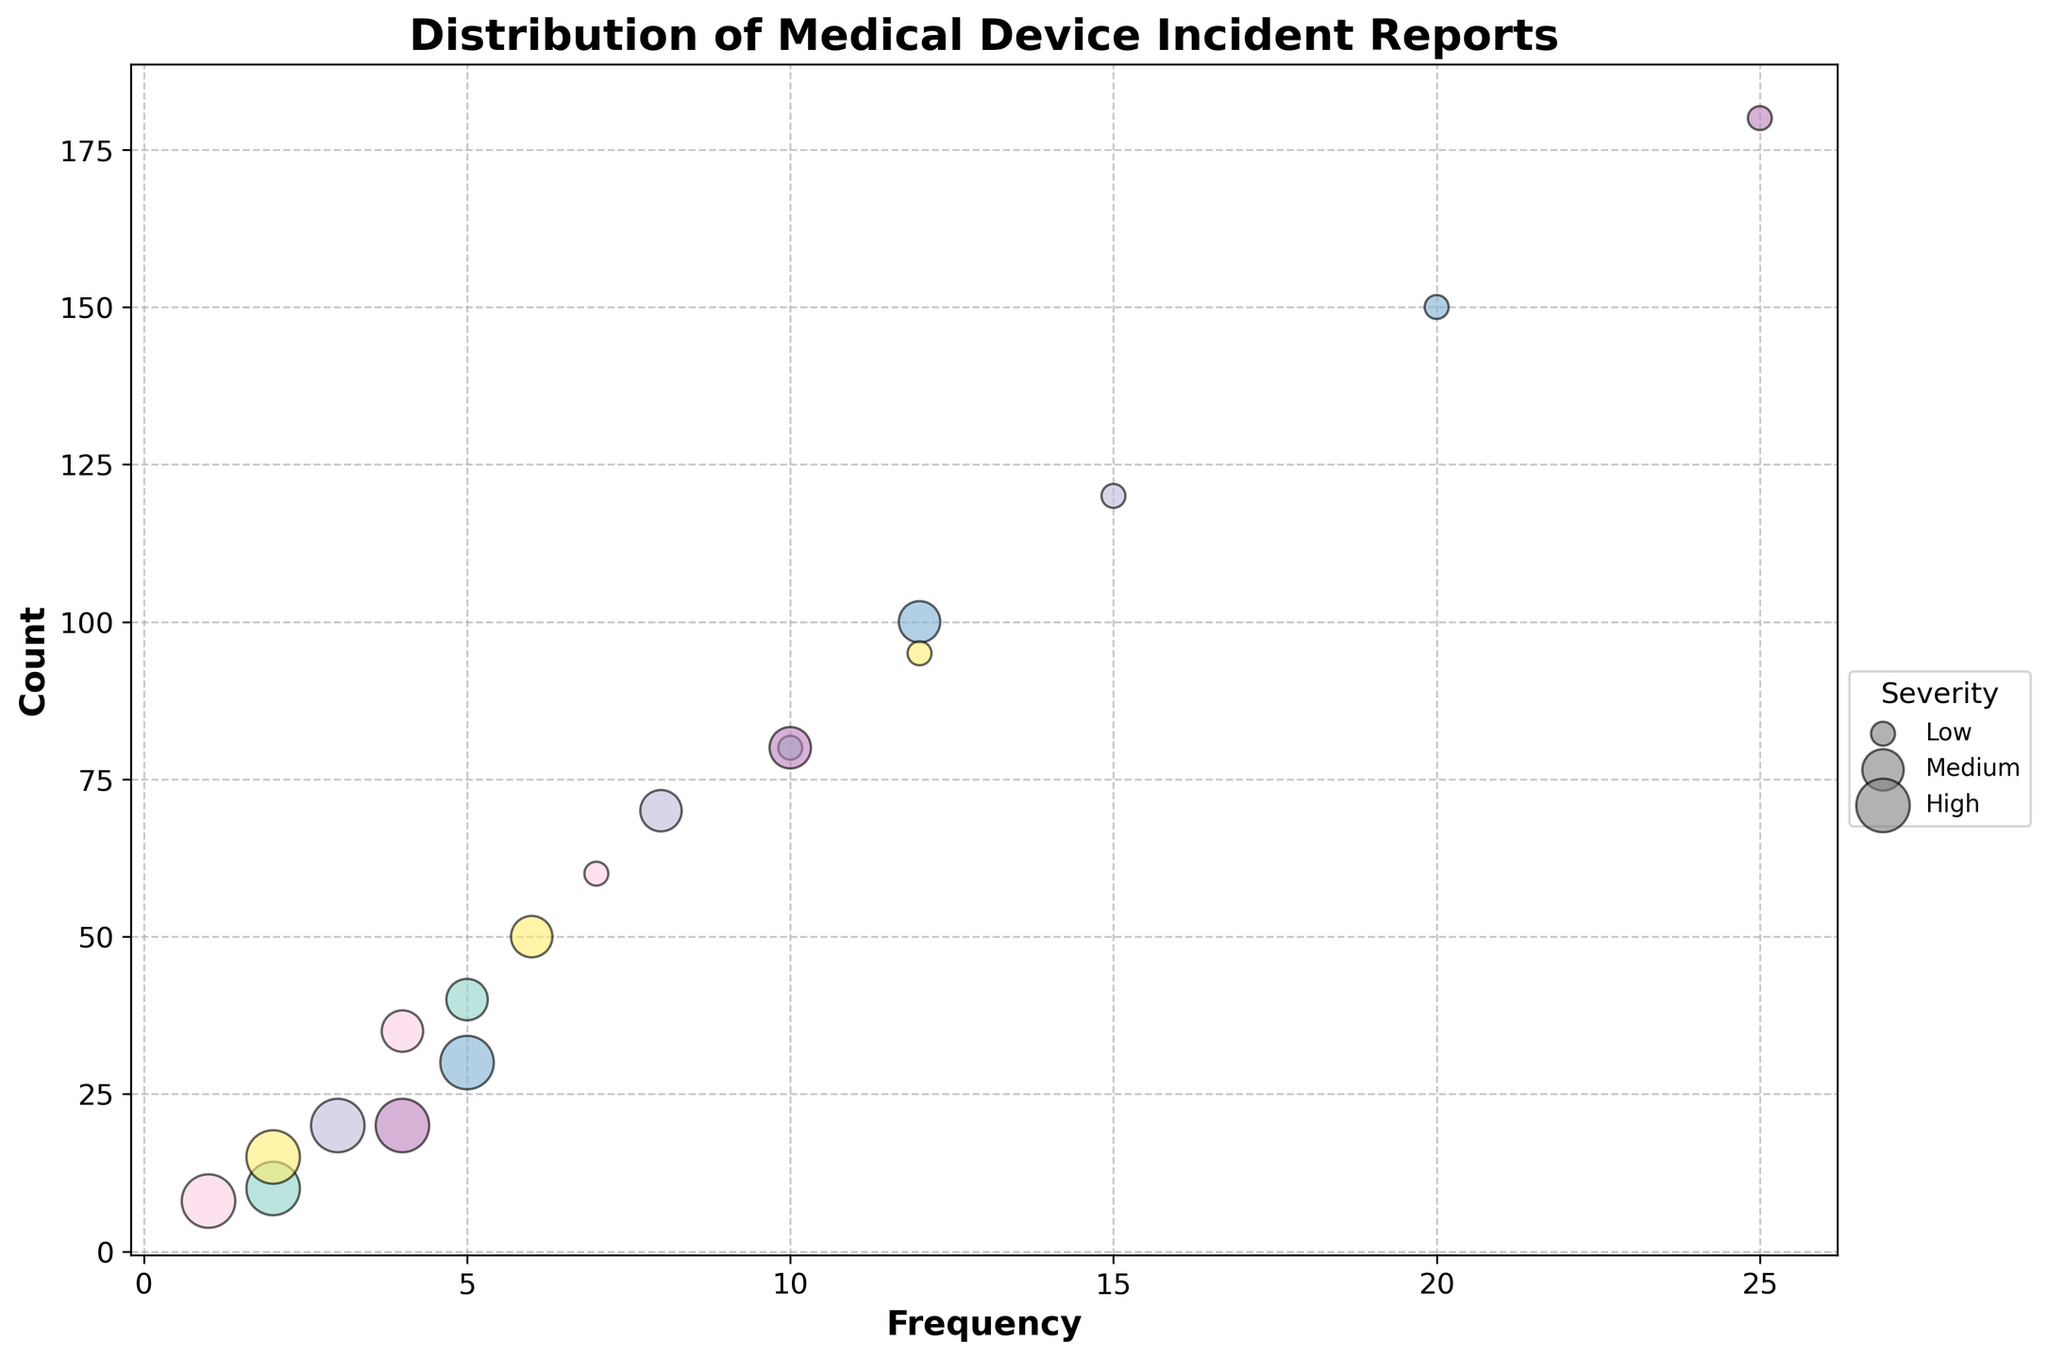what is the title of the figure? The title of the figure is located at the top and provides a summary of what the plot is about. It helps users quickly understand the context. For this chart, the title indicates that it shows the distribution of incident reports for different types of medical devices.
Answer: Distribution of Medical Device Incident Reports how many device types are analyzed in the figure? By observing the unique color-coded legends on the chart, we can count the different device types represented. Each device type is indicated by a different color.
Answer: 6 which device type has the highest count for low severity incidents? To identify this, look for the largest bubble in the "Low" legend category. The bubble with the highest count value will be the largest on the y-axis. This device is the Diagnostic Imaging Device.
Answer: Diagnostic Imaging Device compare the frequency of medium severity incidents between surgical stapler and cardiac pacemaker First, locate the medium severity bubbles for both the Surgical Stapler and the Cardiac Pacemaker on the chart. Compare their position on the x-axis to determine which has a higher frequency.
Answer: Surgical Stapler has a higher frequency than Cardiac Pacemaker which device type appears to have the smallest bubble for high severity incidents? To determine this, locate the smallest bubble under the high severity category in the chart. Compare the bubbles corresponding to each device type with high severity incidents. The Orthopedic Implant has the smallest bubble.
Answer: Orthopedic Implant what is the relationship between frequency and count for the insulin pump in medium severity incidents? Look for the bubble representing medium severity incidents for the Insulin Pump. Identify its position on both the x-axis (frequency) and the y-axis (count). The position indicates that with an increase in frequency (8), the count is 70. This suggests that medium frequency incidents have a higher count for this device.
Answer: Frequency: 8, Count: 70 if you add the counts of high severity incidents for all device types, what is the total? Sum the counts of high severity incidents for each device type: Cardiac Pacemaker (10) + Insulin Pump (20) + Surgical Stapler (30) + Orthopedic Implant (8) + Diagnostic Imaging Device (20) + Dialysis Machine (15).
Answer: 103 which device has the largest bubble overall, and what does it represent? The largest bubble will be the one with the highest count and largest size. Look for the bubble size in all severity categories and determine which device it corresponds to. The Diagnostic Imaging Device with 180 counts and low severity represents the largest bubble.
Answer: Diagnostic Imaging Device (Low severity, 180 counts) for diagnosing frequency of incidents over count, which device shows a positive linear trend in low severity? Observing the positions of the bubbles for low severity, identify a device whose bubbles form a roughly straight line, indicating a positive relationship between frequency and count. For Low severity incidents, Surgical Stapler demonstrates this trend.
Answer: Surgical Stapler what kind of legend elements are used to indicate severity levels in the chart? The legend elements used for severity levels are circles of different sizes located on the side of the chart. They help users distinguish between low, medium, and high severity based on bubble size.
Answer: Circles of different sizes 